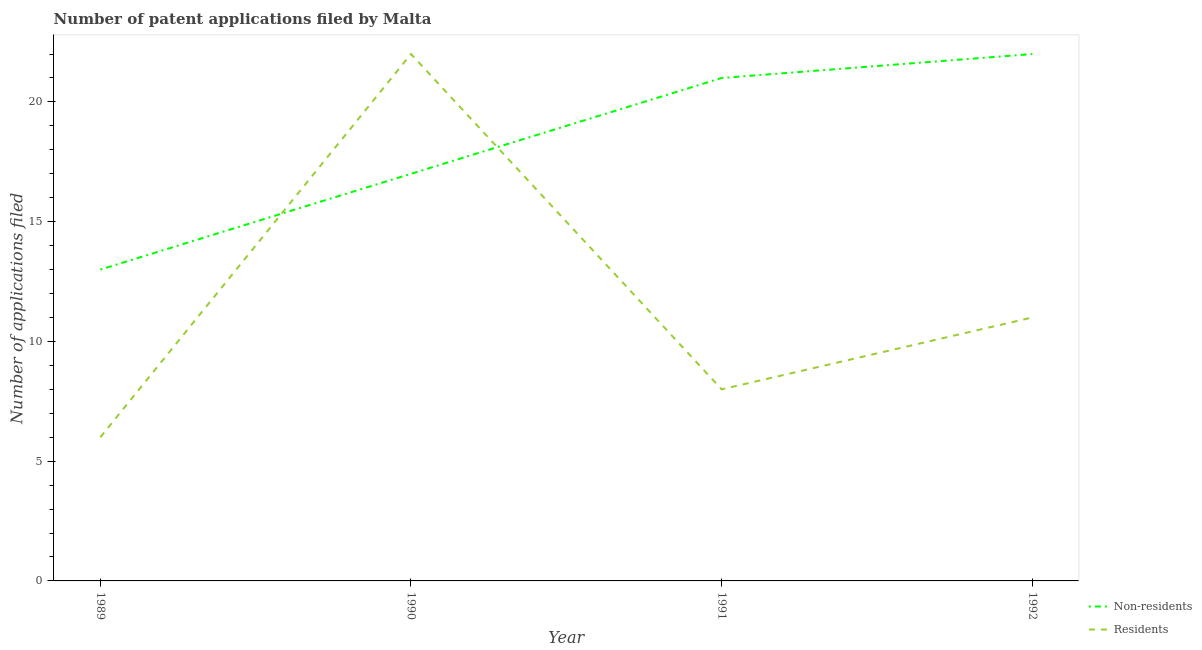How many different coloured lines are there?
Make the answer very short. 2. What is the number of patent applications by non residents in 1992?
Your response must be concise. 22. Across all years, what is the maximum number of patent applications by residents?
Your response must be concise. 22. Across all years, what is the minimum number of patent applications by non residents?
Your answer should be very brief. 13. In which year was the number of patent applications by non residents maximum?
Your answer should be very brief. 1992. What is the total number of patent applications by residents in the graph?
Make the answer very short. 47. What is the difference between the number of patent applications by residents in 1991 and that in 1992?
Ensure brevity in your answer.  -3. What is the difference between the number of patent applications by residents in 1992 and the number of patent applications by non residents in 1990?
Provide a short and direct response. -6. What is the average number of patent applications by non residents per year?
Make the answer very short. 18.25. In the year 1990, what is the difference between the number of patent applications by non residents and number of patent applications by residents?
Give a very brief answer. -5. In how many years, is the number of patent applications by residents greater than 15?
Offer a terse response. 1. What is the ratio of the number of patent applications by residents in 1990 to that in 1992?
Provide a succinct answer. 2. Is the number of patent applications by residents in 1989 less than that in 1992?
Provide a succinct answer. Yes. Is the difference between the number of patent applications by non residents in 1990 and 1991 greater than the difference between the number of patent applications by residents in 1990 and 1991?
Ensure brevity in your answer.  No. What is the difference between the highest and the second highest number of patent applications by residents?
Ensure brevity in your answer.  11. What is the difference between the highest and the lowest number of patent applications by residents?
Your answer should be compact. 16. In how many years, is the number of patent applications by non residents greater than the average number of patent applications by non residents taken over all years?
Your answer should be very brief. 2. Is the sum of the number of patent applications by non residents in 1989 and 1991 greater than the maximum number of patent applications by residents across all years?
Ensure brevity in your answer.  Yes. How many lines are there?
Your answer should be compact. 2. How many years are there in the graph?
Offer a terse response. 4. What is the difference between two consecutive major ticks on the Y-axis?
Your response must be concise. 5. Where does the legend appear in the graph?
Your response must be concise. Bottom right. What is the title of the graph?
Offer a very short reply. Number of patent applications filed by Malta. What is the label or title of the X-axis?
Make the answer very short. Year. What is the label or title of the Y-axis?
Your answer should be compact. Number of applications filed. What is the Number of applications filed in Residents in 1989?
Give a very brief answer. 6. What is the Number of applications filed in Non-residents in 1990?
Your answer should be very brief. 17. What is the Number of applications filed in Residents in 1991?
Your answer should be very brief. 8. What is the Number of applications filed in Non-residents in 1992?
Make the answer very short. 22. What is the Number of applications filed in Residents in 1992?
Your answer should be compact. 11. Across all years, what is the maximum Number of applications filed of Non-residents?
Keep it short and to the point. 22. Across all years, what is the minimum Number of applications filed of Residents?
Keep it short and to the point. 6. What is the total Number of applications filed in Non-residents in the graph?
Keep it short and to the point. 73. What is the difference between the Number of applications filed in Non-residents in 1989 and that in 1990?
Your answer should be compact. -4. What is the difference between the Number of applications filed of Residents in 1989 and that in 1990?
Offer a terse response. -16. What is the difference between the Number of applications filed of Residents in 1990 and that in 1991?
Your answer should be compact. 14. What is the difference between the Number of applications filed in Non-residents in 1990 and that in 1992?
Give a very brief answer. -5. What is the difference between the Number of applications filed of Residents in 1990 and that in 1992?
Your answer should be very brief. 11. What is the difference between the Number of applications filed in Non-residents in 1991 and that in 1992?
Provide a succinct answer. -1. What is the difference between the Number of applications filed in Non-residents in 1989 and the Number of applications filed in Residents in 1992?
Your answer should be very brief. 2. What is the difference between the Number of applications filed of Non-residents in 1990 and the Number of applications filed of Residents in 1991?
Your answer should be compact. 9. What is the average Number of applications filed in Non-residents per year?
Your answer should be compact. 18.25. What is the average Number of applications filed of Residents per year?
Provide a short and direct response. 11.75. What is the ratio of the Number of applications filed of Non-residents in 1989 to that in 1990?
Provide a short and direct response. 0.76. What is the ratio of the Number of applications filed in Residents in 1989 to that in 1990?
Your response must be concise. 0.27. What is the ratio of the Number of applications filed of Non-residents in 1989 to that in 1991?
Ensure brevity in your answer.  0.62. What is the ratio of the Number of applications filed in Residents in 1989 to that in 1991?
Provide a succinct answer. 0.75. What is the ratio of the Number of applications filed in Non-residents in 1989 to that in 1992?
Ensure brevity in your answer.  0.59. What is the ratio of the Number of applications filed of Residents in 1989 to that in 1992?
Keep it short and to the point. 0.55. What is the ratio of the Number of applications filed of Non-residents in 1990 to that in 1991?
Keep it short and to the point. 0.81. What is the ratio of the Number of applications filed in Residents in 1990 to that in 1991?
Ensure brevity in your answer.  2.75. What is the ratio of the Number of applications filed of Non-residents in 1990 to that in 1992?
Offer a very short reply. 0.77. What is the ratio of the Number of applications filed in Residents in 1990 to that in 1992?
Your answer should be compact. 2. What is the ratio of the Number of applications filed in Non-residents in 1991 to that in 1992?
Your answer should be very brief. 0.95. What is the ratio of the Number of applications filed in Residents in 1991 to that in 1992?
Offer a terse response. 0.73. What is the difference between the highest and the lowest Number of applications filed in Residents?
Your answer should be very brief. 16. 